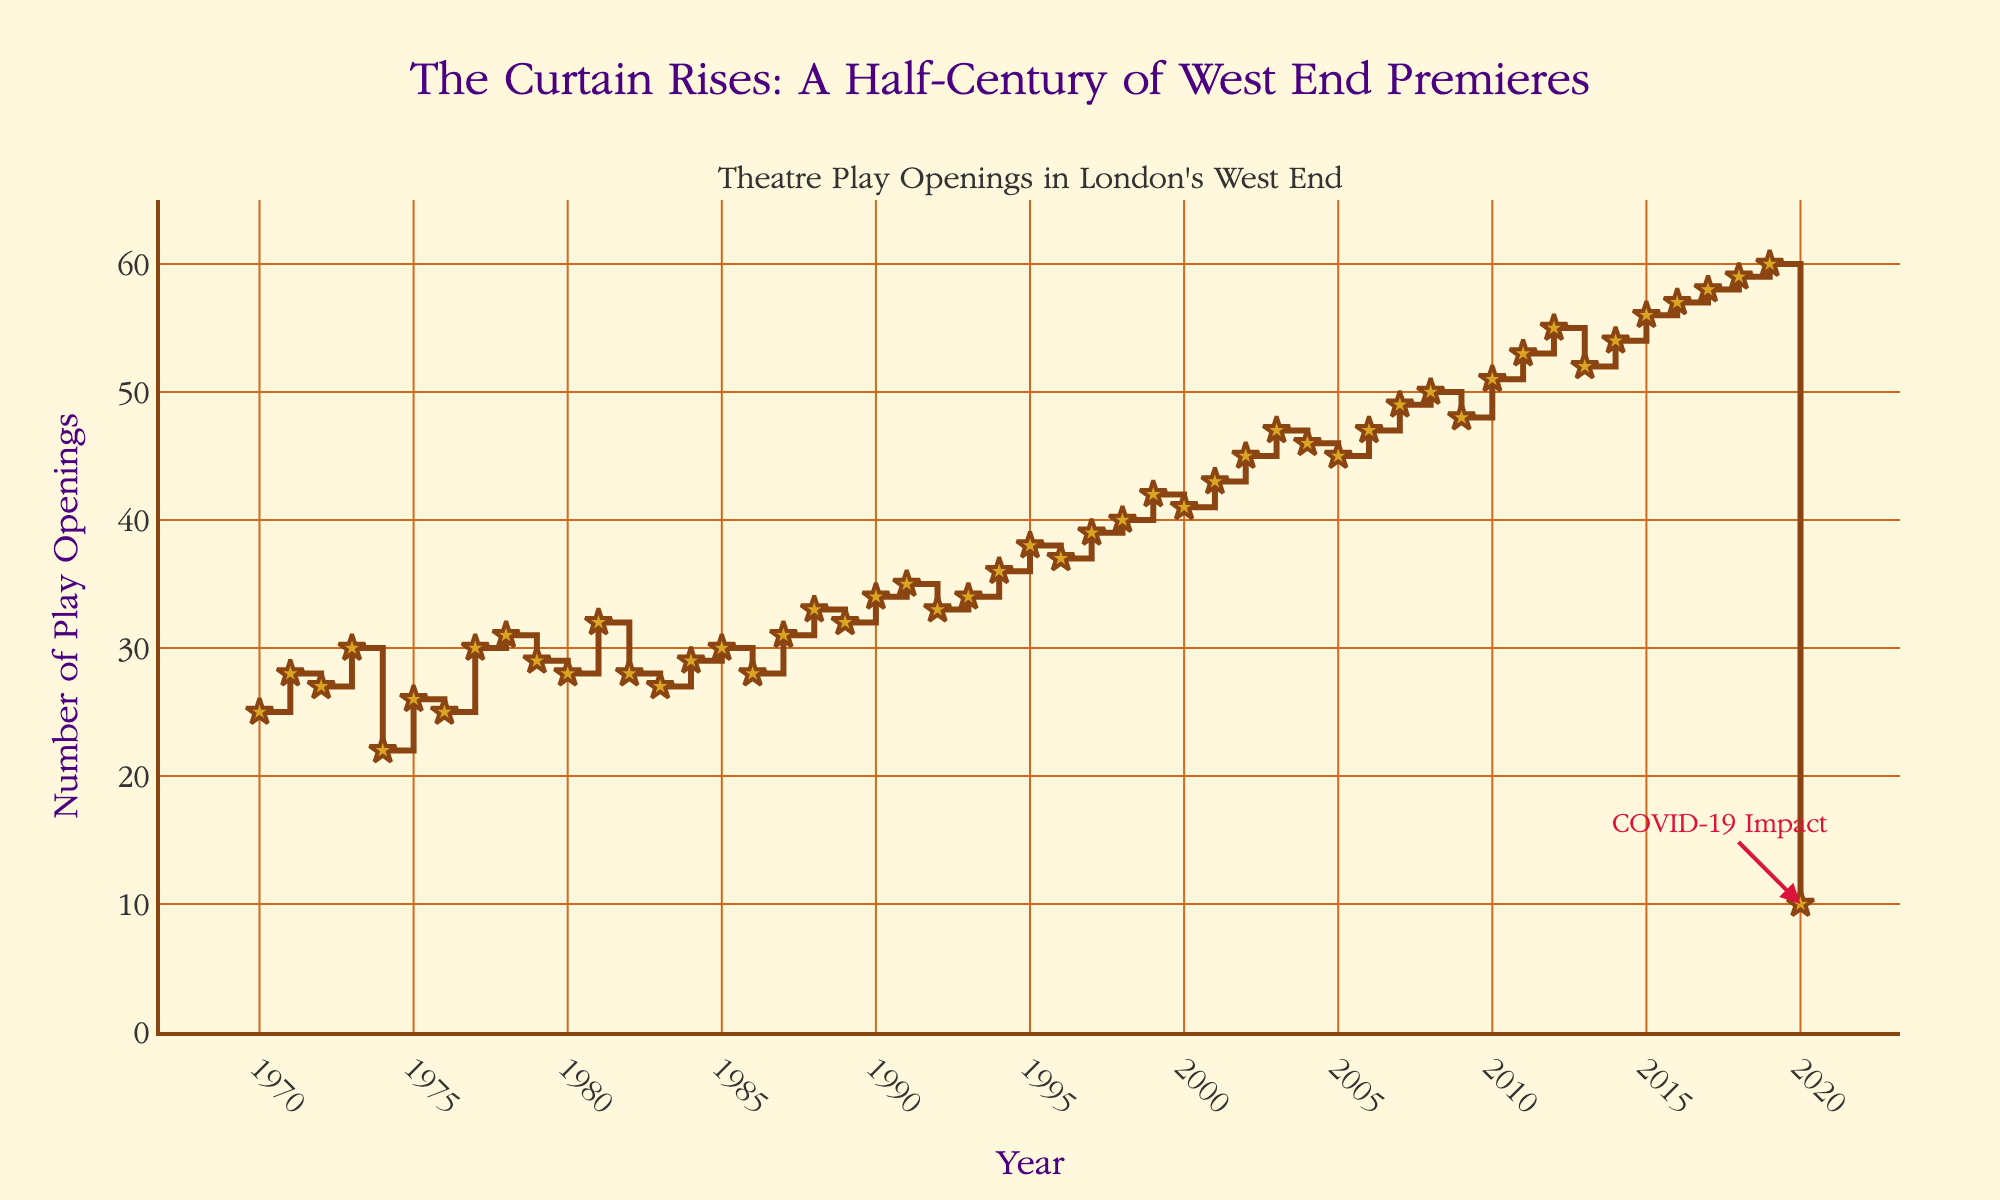What's the title of the figure? The title is located at the top of the figure. It is "The Curtain Rises: A Half-Century of West End Premieres".
Answer: The Curtain Rises: A Half-Century of West End Premieres How many years are covered in the plot? The x-axis labels years from 1970 to 2020. To determine the number of years covered, count the years inclusive: 2020 - 1970 + 1.
Answer: 51 Which year had the highest number of play openings before 2020? Look for the peak points on the y-axis before 2020; the highest value appears at 2019 with a value of 60.
Answer: 2019 What is the number of play openings in 2020? According to the data, the number of play openings in 2020 is marked at 10.
Answer: 10 What do the x and y axes represent? The x-axis represents the years from 1970 to 2020, and the y-axis represents the number of play openings annually in London’s West End.
Answer: Years and the number of play openings How many more plays opened in 2015 compared to 1975? Refer to the points for 2015 and 1975 on the plot. In 2015, 56 plays opened, and in 1975, 26 plays opened. The difference is 56 - 26.
Answer: 30 What noticeable annotation is added to the figure? The annotation points to the year 2020 and mentions "COVID-19 Impact", signifying the drop in the number of play openings due to the pandemic.
Answer: COVID-19 Impact What trend can be inferred between 1970 and 1990? Observe the overall trend of the number of play openings between 1970 and 1990. There is a general increase, from around 25 in 1970 to about 34 in 1990.
Answer: Increasing trend How does the number of play openings change from 2002 to 2006? During 2002, the number of play openings is 45 and reaches 47 by 2006, indicating a slight increase.
Answer: Increase Which year experienced the second-highest number of play openings, and what was it? Apart from 2019, the second-highest number of play openings is in 2018 with 59.
Answer: 2018, 59 